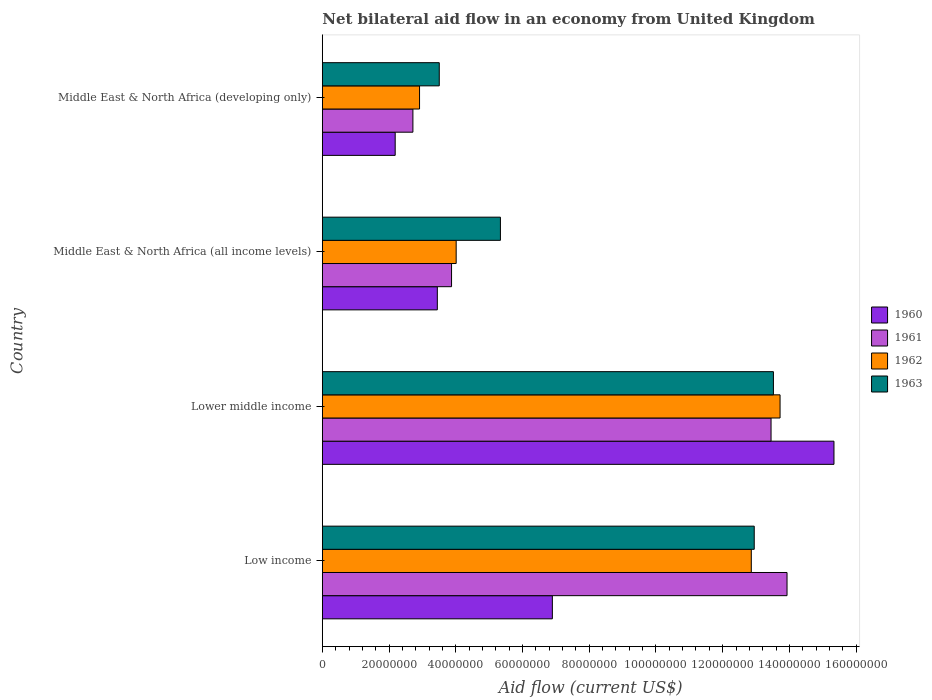How many different coloured bars are there?
Provide a succinct answer. 4. How many groups of bars are there?
Offer a terse response. 4. Are the number of bars per tick equal to the number of legend labels?
Offer a very short reply. Yes. How many bars are there on the 2nd tick from the top?
Provide a short and direct response. 4. How many bars are there on the 1st tick from the bottom?
Your response must be concise. 4. What is the label of the 1st group of bars from the top?
Keep it short and to the point. Middle East & North Africa (developing only). In how many cases, is the number of bars for a given country not equal to the number of legend labels?
Your response must be concise. 0. What is the net bilateral aid flow in 1962 in Low income?
Ensure brevity in your answer.  1.29e+08. Across all countries, what is the maximum net bilateral aid flow in 1961?
Give a very brief answer. 1.39e+08. Across all countries, what is the minimum net bilateral aid flow in 1962?
Your answer should be compact. 2.91e+07. In which country was the net bilateral aid flow in 1963 maximum?
Give a very brief answer. Lower middle income. In which country was the net bilateral aid flow in 1961 minimum?
Offer a terse response. Middle East & North Africa (developing only). What is the total net bilateral aid flow in 1961 in the graph?
Provide a succinct answer. 3.40e+08. What is the difference between the net bilateral aid flow in 1960 in Low income and that in Middle East & North Africa (all income levels)?
Your response must be concise. 3.45e+07. What is the difference between the net bilateral aid flow in 1961 in Lower middle income and the net bilateral aid flow in 1962 in Low income?
Make the answer very short. 5.92e+06. What is the average net bilateral aid flow in 1962 per country?
Make the answer very short. 8.38e+07. What is the difference between the net bilateral aid flow in 1963 and net bilateral aid flow in 1962 in Middle East & North Africa (developing only)?
Give a very brief answer. 5.91e+06. What is the ratio of the net bilateral aid flow in 1961 in Low income to that in Middle East & North Africa (all income levels)?
Offer a terse response. 3.6. Is the difference between the net bilateral aid flow in 1963 in Low income and Lower middle income greater than the difference between the net bilateral aid flow in 1962 in Low income and Lower middle income?
Offer a terse response. Yes. What is the difference between the highest and the second highest net bilateral aid flow in 1963?
Your answer should be very brief. 5.75e+06. What is the difference between the highest and the lowest net bilateral aid flow in 1962?
Make the answer very short. 1.08e+08. Is the sum of the net bilateral aid flow in 1962 in Lower middle income and Middle East & North Africa (all income levels) greater than the maximum net bilateral aid flow in 1960 across all countries?
Provide a succinct answer. Yes. What does the 3rd bar from the top in Low income represents?
Give a very brief answer. 1961. Is it the case that in every country, the sum of the net bilateral aid flow in 1960 and net bilateral aid flow in 1963 is greater than the net bilateral aid flow in 1961?
Ensure brevity in your answer.  Yes. How many bars are there?
Keep it short and to the point. 16. What is the difference between two consecutive major ticks on the X-axis?
Your answer should be compact. 2.00e+07. Are the values on the major ticks of X-axis written in scientific E-notation?
Offer a very short reply. No. Does the graph contain any zero values?
Keep it short and to the point. No. Where does the legend appear in the graph?
Provide a short and direct response. Center right. What is the title of the graph?
Make the answer very short. Net bilateral aid flow in an economy from United Kingdom. What is the label or title of the X-axis?
Your response must be concise. Aid flow (current US$). What is the Aid flow (current US$) in 1960 in Low income?
Provide a short and direct response. 6.90e+07. What is the Aid flow (current US$) in 1961 in Low income?
Your answer should be very brief. 1.39e+08. What is the Aid flow (current US$) in 1962 in Low income?
Provide a succinct answer. 1.29e+08. What is the Aid flow (current US$) in 1963 in Low income?
Your answer should be very brief. 1.29e+08. What is the Aid flow (current US$) of 1960 in Lower middle income?
Ensure brevity in your answer.  1.53e+08. What is the Aid flow (current US$) in 1961 in Lower middle income?
Offer a very short reply. 1.34e+08. What is the Aid flow (current US$) in 1962 in Lower middle income?
Offer a terse response. 1.37e+08. What is the Aid flow (current US$) of 1963 in Lower middle income?
Your response must be concise. 1.35e+08. What is the Aid flow (current US$) in 1960 in Middle East & North Africa (all income levels)?
Provide a succinct answer. 3.45e+07. What is the Aid flow (current US$) of 1961 in Middle East & North Africa (all income levels)?
Ensure brevity in your answer.  3.87e+07. What is the Aid flow (current US$) of 1962 in Middle East & North Africa (all income levels)?
Offer a very short reply. 4.01e+07. What is the Aid flow (current US$) in 1963 in Middle East & North Africa (all income levels)?
Your answer should be compact. 5.34e+07. What is the Aid flow (current US$) of 1960 in Middle East & North Africa (developing only)?
Provide a succinct answer. 2.18e+07. What is the Aid flow (current US$) of 1961 in Middle East & North Africa (developing only)?
Provide a succinct answer. 2.72e+07. What is the Aid flow (current US$) of 1962 in Middle East & North Africa (developing only)?
Make the answer very short. 2.91e+07. What is the Aid flow (current US$) of 1963 in Middle East & North Africa (developing only)?
Offer a very short reply. 3.50e+07. Across all countries, what is the maximum Aid flow (current US$) in 1960?
Make the answer very short. 1.53e+08. Across all countries, what is the maximum Aid flow (current US$) of 1961?
Your response must be concise. 1.39e+08. Across all countries, what is the maximum Aid flow (current US$) of 1962?
Ensure brevity in your answer.  1.37e+08. Across all countries, what is the maximum Aid flow (current US$) in 1963?
Your answer should be very brief. 1.35e+08. Across all countries, what is the minimum Aid flow (current US$) of 1960?
Offer a very short reply. 2.18e+07. Across all countries, what is the minimum Aid flow (current US$) of 1961?
Keep it short and to the point. 2.72e+07. Across all countries, what is the minimum Aid flow (current US$) in 1962?
Provide a succinct answer. 2.91e+07. Across all countries, what is the minimum Aid flow (current US$) of 1963?
Offer a terse response. 3.50e+07. What is the total Aid flow (current US$) in 1960 in the graph?
Give a very brief answer. 2.79e+08. What is the total Aid flow (current US$) in 1961 in the graph?
Make the answer very short. 3.40e+08. What is the total Aid flow (current US$) of 1962 in the graph?
Give a very brief answer. 3.35e+08. What is the total Aid flow (current US$) of 1963 in the graph?
Your answer should be compact. 3.53e+08. What is the difference between the Aid flow (current US$) of 1960 in Low income and that in Lower middle income?
Your answer should be very brief. -8.44e+07. What is the difference between the Aid flow (current US$) of 1961 in Low income and that in Lower middle income?
Provide a short and direct response. 4.79e+06. What is the difference between the Aid flow (current US$) of 1962 in Low income and that in Lower middle income?
Provide a short and direct response. -8.62e+06. What is the difference between the Aid flow (current US$) of 1963 in Low income and that in Lower middle income?
Offer a very short reply. -5.75e+06. What is the difference between the Aid flow (current US$) in 1960 in Low income and that in Middle East & North Africa (all income levels)?
Provide a succinct answer. 3.45e+07. What is the difference between the Aid flow (current US$) of 1961 in Low income and that in Middle East & North Africa (all income levels)?
Offer a terse response. 1.01e+08. What is the difference between the Aid flow (current US$) in 1962 in Low income and that in Middle East & North Africa (all income levels)?
Ensure brevity in your answer.  8.85e+07. What is the difference between the Aid flow (current US$) of 1963 in Low income and that in Middle East & North Africa (all income levels)?
Offer a terse response. 7.61e+07. What is the difference between the Aid flow (current US$) in 1960 in Low income and that in Middle East & North Africa (developing only)?
Make the answer very short. 4.71e+07. What is the difference between the Aid flow (current US$) of 1961 in Low income and that in Middle East & North Africa (developing only)?
Provide a succinct answer. 1.12e+08. What is the difference between the Aid flow (current US$) in 1962 in Low income and that in Middle East & North Africa (developing only)?
Provide a succinct answer. 9.94e+07. What is the difference between the Aid flow (current US$) in 1963 in Low income and that in Middle East & North Africa (developing only)?
Your response must be concise. 9.44e+07. What is the difference between the Aid flow (current US$) in 1960 in Lower middle income and that in Middle East & North Africa (all income levels)?
Provide a succinct answer. 1.19e+08. What is the difference between the Aid flow (current US$) of 1961 in Lower middle income and that in Middle East & North Africa (all income levels)?
Provide a short and direct response. 9.58e+07. What is the difference between the Aid flow (current US$) of 1962 in Lower middle income and that in Middle East & North Africa (all income levels)?
Give a very brief answer. 9.71e+07. What is the difference between the Aid flow (current US$) of 1963 in Lower middle income and that in Middle East & North Africa (all income levels)?
Your answer should be compact. 8.18e+07. What is the difference between the Aid flow (current US$) in 1960 in Lower middle income and that in Middle East & North Africa (developing only)?
Your answer should be very brief. 1.32e+08. What is the difference between the Aid flow (current US$) of 1961 in Lower middle income and that in Middle East & North Africa (developing only)?
Provide a short and direct response. 1.07e+08. What is the difference between the Aid flow (current US$) of 1962 in Lower middle income and that in Middle East & North Africa (developing only)?
Your answer should be compact. 1.08e+08. What is the difference between the Aid flow (current US$) in 1963 in Lower middle income and that in Middle East & North Africa (developing only)?
Provide a succinct answer. 1.00e+08. What is the difference between the Aid flow (current US$) in 1960 in Middle East & North Africa (all income levels) and that in Middle East & North Africa (developing only)?
Your answer should be very brief. 1.26e+07. What is the difference between the Aid flow (current US$) in 1961 in Middle East & North Africa (all income levels) and that in Middle East & North Africa (developing only)?
Your answer should be compact. 1.16e+07. What is the difference between the Aid flow (current US$) in 1962 in Middle East & North Africa (all income levels) and that in Middle East & North Africa (developing only)?
Provide a succinct answer. 1.10e+07. What is the difference between the Aid flow (current US$) of 1963 in Middle East & North Africa (all income levels) and that in Middle East & North Africa (developing only)?
Provide a short and direct response. 1.83e+07. What is the difference between the Aid flow (current US$) in 1960 in Low income and the Aid flow (current US$) in 1961 in Lower middle income?
Make the answer very short. -6.56e+07. What is the difference between the Aid flow (current US$) in 1960 in Low income and the Aid flow (current US$) in 1962 in Lower middle income?
Provide a succinct answer. -6.82e+07. What is the difference between the Aid flow (current US$) in 1960 in Low income and the Aid flow (current US$) in 1963 in Lower middle income?
Make the answer very short. -6.63e+07. What is the difference between the Aid flow (current US$) of 1961 in Low income and the Aid flow (current US$) of 1962 in Lower middle income?
Ensure brevity in your answer.  2.09e+06. What is the difference between the Aid flow (current US$) in 1961 in Low income and the Aid flow (current US$) in 1963 in Lower middle income?
Make the answer very short. 4.08e+06. What is the difference between the Aid flow (current US$) in 1962 in Low income and the Aid flow (current US$) in 1963 in Lower middle income?
Provide a succinct answer. -6.63e+06. What is the difference between the Aid flow (current US$) in 1960 in Low income and the Aid flow (current US$) in 1961 in Middle East & North Africa (all income levels)?
Give a very brief answer. 3.02e+07. What is the difference between the Aid flow (current US$) in 1960 in Low income and the Aid flow (current US$) in 1962 in Middle East & North Africa (all income levels)?
Your response must be concise. 2.88e+07. What is the difference between the Aid flow (current US$) in 1960 in Low income and the Aid flow (current US$) in 1963 in Middle East & North Africa (all income levels)?
Keep it short and to the point. 1.56e+07. What is the difference between the Aid flow (current US$) in 1961 in Low income and the Aid flow (current US$) in 1962 in Middle East & North Africa (all income levels)?
Offer a very short reply. 9.92e+07. What is the difference between the Aid flow (current US$) of 1961 in Low income and the Aid flow (current US$) of 1963 in Middle East & North Africa (all income levels)?
Ensure brevity in your answer.  8.59e+07. What is the difference between the Aid flow (current US$) of 1962 in Low income and the Aid flow (current US$) of 1963 in Middle East & North Africa (all income levels)?
Ensure brevity in your answer.  7.52e+07. What is the difference between the Aid flow (current US$) of 1960 in Low income and the Aid flow (current US$) of 1961 in Middle East & North Africa (developing only)?
Ensure brevity in your answer.  4.18e+07. What is the difference between the Aid flow (current US$) in 1960 in Low income and the Aid flow (current US$) in 1962 in Middle East & North Africa (developing only)?
Make the answer very short. 3.98e+07. What is the difference between the Aid flow (current US$) in 1960 in Low income and the Aid flow (current US$) in 1963 in Middle East & North Africa (developing only)?
Your answer should be compact. 3.39e+07. What is the difference between the Aid flow (current US$) in 1961 in Low income and the Aid flow (current US$) in 1962 in Middle East & North Africa (developing only)?
Offer a very short reply. 1.10e+08. What is the difference between the Aid flow (current US$) in 1961 in Low income and the Aid flow (current US$) in 1963 in Middle East & North Africa (developing only)?
Offer a very short reply. 1.04e+08. What is the difference between the Aid flow (current US$) in 1962 in Low income and the Aid flow (current US$) in 1963 in Middle East & North Africa (developing only)?
Your answer should be very brief. 9.35e+07. What is the difference between the Aid flow (current US$) in 1960 in Lower middle income and the Aid flow (current US$) in 1961 in Middle East & North Africa (all income levels)?
Offer a very short reply. 1.15e+08. What is the difference between the Aid flow (current US$) in 1960 in Lower middle income and the Aid flow (current US$) in 1962 in Middle East & North Africa (all income levels)?
Your answer should be compact. 1.13e+08. What is the difference between the Aid flow (current US$) of 1960 in Lower middle income and the Aid flow (current US$) of 1963 in Middle East & North Africa (all income levels)?
Provide a succinct answer. 1.00e+08. What is the difference between the Aid flow (current US$) of 1961 in Lower middle income and the Aid flow (current US$) of 1962 in Middle East & North Africa (all income levels)?
Give a very brief answer. 9.44e+07. What is the difference between the Aid flow (current US$) in 1961 in Lower middle income and the Aid flow (current US$) in 1963 in Middle East & North Africa (all income levels)?
Ensure brevity in your answer.  8.11e+07. What is the difference between the Aid flow (current US$) in 1962 in Lower middle income and the Aid flow (current US$) in 1963 in Middle East & North Africa (all income levels)?
Keep it short and to the point. 8.38e+07. What is the difference between the Aid flow (current US$) in 1960 in Lower middle income and the Aid flow (current US$) in 1961 in Middle East & North Africa (developing only)?
Make the answer very short. 1.26e+08. What is the difference between the Aid flow (current US$) in 1960 in Lower middle income and the Aid flow (current US$) in 1962 in Middle East & North Africa (developing only)?
Your response must be concise. 1.24e+08. What is the difference between the Aid flow (current US$) of 1960 in Lower middle income and the Aid flow (current US$) of 1963 in Middle East & North Africa (developing only)?
Make the answer very short. 1.18e+08. What is the difference between the Aid flow (current US$) in 1961 in Lower middle income and the Aid flow (current US$) in 1962 in Middle East & North Africa (developing only)?
Your response must be concise. 1.05e+08. What is the difference between the Aid flow (current US$) of 1961 in Lower middle income and the Aid flow (current US$) of 1963 in Middle East & North Africa (developing only)?
Your answer should be very brief. 9.94e+07. What is the difference between the Aid flow (current US$) in 1962 in Lower middle income and the Aid flow (current US$) in 1963 in Middle East & North Africa (developing only)?
Keep it short and to the point. 1.02e+08. What is the difference between the Aid flow (current US$) in 1960 in Middle East & North Africa (all income levels) and the Aid flow (current US$) in 1961 in Middle East & North Africa (developing only)?
Your answer should be compact. 7.32e+06. What is the difference between the Aid flow (current US$) of 1960 in Middle East & North Africa (all income levels) and the Aid flow (current US$) of 1962 in Middle East & North Africa (developing only)?
Keep it short and to the point. 5.33e+06. What is the difference between the Aid flow (current US$) of 1960 in Middle East & North Africa (all income levels) and the Aid flow (current US$) of 1963 in Middle East & North Africa (developing only)?
Your answer should be very brief. -5.80e+05. What is the difference between the Aid flow (current US$) in 1961 in Middle East & North Africa (all income levels) and the Aid flow (current US$) in 1962 in Middle East & North Africa (developing only)?
Keep it short and to the point. 9.59e+06. What is the difference between the Aid flow (current US$) in 1961 in Middle East & North Africa (all income levels) and the Aid flow (current US$) in 1963 in Middle East & North Africa (developing only)?
Make the answer very short. 3.68e+06. What is the difference between the Aid flow (current US$) of 1962 in Middle East & North Africa (all income levels) and the Aid flow (current US$) of 1963 in Middle East & North Africa (developing only)?
Ensure brevity in your answer.  5.07e+06. What is the average Aid flow (current US$) of 1960 per country?
Your answer should be compact. 6.97e+07. What is the average Aid flow (current US$) in 1961 per country?
Ensure brevity in your answer.  8.49e+07. What is the average Aid flow (current US$) of 1962 per country?
Your answer should be compact. 8.38e+07. What is the average Aid flow (current US$) in 1963 per country?
Your answer should be compact. 8.83e+07. What is the difference between the Aid flow (current US$) of 1960 and Aid flow (current US$) of 1961 in Low income?
Give a very brief answer. -7.03e+07. What is the difference between the Aid flow (current US$) in 1960 and Aid flow (current US$) in 1962 in Low income?
Ensure brevity in your answer.  -5.96e+07. What is the difference between the Aid flow (current US$) of 1960 and Aid flow (current US$) of 1963 in Low income?
Provide a short and direct response. -6.05e+07. What is the difference between the Aid flow (current US$) in 1961 and Aid flow (current US$) in 1962 in Low income?
Provide a succinct answer. 1.07e+07. What is the difference between the Aid flow (current US$) in 1961 and Aid flow (current US$) in 1963 in Low income?
Ensure brevity in your answer.  9.83e+06. What is the difference between the Aid flow (current US$) of 1962 and Aid flow (current US$) of 1963 in Low income?
Offer a terse response. -8.80e+05. What is the difference between the Aid flow (current US$) in 1960 and Aid flow (current US$) in 1961 in Lower middle income?
Keep it short and to the point. 1.89e+07. What is the difference between the Aid flow (current US$) in 1960 and Aid flow (current US$) in 1962 in Lower middle income?
Offer a terse response. 1.62e+07. What is the difference between the Aid flow (current US$) in 1960 and Aid flow (current US$) in 1963 in Lower middle income?
Make the answer very short. 1.82e+07. What is the difference between the Aid flow (current US$) in 1961 and Aid flow (current US$) in 1962 in Lower middle income?
Make the answer very short. -2.70e+06. What is the difference between the Aid flow (current US$) in 1961 and Aid flow (current US$) in 1963 in Lower middle income?
Offer a very short reply. -7.10e+05. What is the difference between the Aid flow (current US$) of 1962 and Aid flow (current US$) of 1963 in Lower middle income?
Your response must be concise. 1.99e+06. What is the difference between the Aid flow (current US$) in 1960 and Aid flow (current US$) in 1961 in Middle East & North Africa (all income levels)?
Ensure brevity in your answer.  -4.26e+06. What is the difference between the Aid flow (current US$) of 1960 and Aid flow (current US$) of 1962 in Middle East & North Africa (all income levels)?
Keep it short and to the point. -5.65e+06. What is the difference between the Aid flow (current US$) in 1960 and Aid flow (current US$) in 1963 in Middle East & North Africa (all income levels)?
Offer a terse response. -1.89e+07. What is the difference between the Aid flow (current US$) of 1961 and Aid flow (current US$) of 1962 in Middle East & North Africa (all income levels)?
Your answer should be compact. -1.39e+06. What is the difference between the Aid flow (current US$) of 1961 and Aid flow (current US$) of 1963 in Middle East & North Africa (all income levels)?
Give a very brief answer. -1.46e+07. What is the difference between the Aid flow (current US$) in 1962 and Aid flow (current US$) in 1963 in Middle East & North Africa (all income levels)?
Offer a very short reply. -1.33e+07. What is the difference between the Aid flow (current US$) in 1960 and Aid flow (current US$) in 1961 in Middle East & North Africa (developing only)?
Your response must be concise. -5.31e+06. What is the difference between the Aid flow (current US$) of 1960 and Aid flow (current US$) of 1962 in Middle East & North Africa (developing only)?
Make the answer very short. -7.30e+06. What is the difference between the Aid flow (current US$) of 1960 and Aid flow (current US$) of 1963 in Middle East & North Africa (developing only)?
Offer a terse response. -1.32e+07. What is the difference between the Aid flow (current US$) in 1961 and Aid flow (current US$) in 1962 in Middle East & North Africa (developing only)?
Your response must be concise. -1.99e+06. What is the difference between the Aid flow (current US$) of 1961 and Aid flow (current US$) of 1963 in Middle East & North Africa (developing only)?
Keep it short and to the point. -7.90e+06. What is the difference between the Aid flow (current US$) in 1962 and Aid flow (current US$) in 1963 in Middle East & North Africa (developing only)?
Your answer should be very brief. -5.91e+06. What is the ratio of the Aid flow (current US$) in 1960 in Low income to that in Lower middle income?
Keep it short and to the point. 0.45. What is the ratio of the Aid flow (current US$) in 1961 in Low income to that in Lower middle income?
Provide a short and direct response. 1.04. What is the ratio of the Aid flow (current US$) in 1962 in Low income to that in Lower middle income?
Give a very brief answer. 0.94. What is the ratio of the Aid flow (current US$) in 1963 in Low income to that in Lower middle income?
Your answer should be very brief. 0.96. What is the ratio of the Aid flow (current US$) of 1960 in Low income to that in Middle East & North Africa (all income levels)?
Keep it short and to the point. 2. What is the ratio of the Aid flow (current US$) of 1961 in Low income to that in Middle East & North Africa (all income levels)?
Make the answer very short. 3.6. What is the ratio of the Aid flow (current US$) in 1962 in Low income to that in Middle East & North Africa (all income levels)?
Give a very brief answer. 3.2. What is the ratio of the Aid flow (current US$) in 1963 in Low income to that in Middle East & North Africa (all income levels)?
Provide a succinct answer. 2.43. What is the ratio of the Aid flow (current US$) of 1960 in Low income to that in Middle East & North Africa (developing only)?
Make the answer very short. 3.16. What is the ratio of the Aid flow (current US$) of 1961 in Low income to that in Middle East & North Africa (developing only)?
Your answer should be very brief. 5.13. What is the ratio of the Aid flow (current US$) of 1962 in Low income to that in Middle East & North Africa (developing only)?
Provide a succinct answer. 4.41. What is the ratio of the Aid flow (current US$) in 1963 in Low income to that in Middle East & North Africa (developing only)?
Provide a short and direct response. 3.69. What is the ratio of the Aid flow (current US$) of 1960 in Lower middle income to that in Middle East & North Africa (all income levels)?
Provide a succinct answer. 4.45. What is the ratio of the Aid flow (current US$) in 1961 in Lower middle income to that in Middle East & North Africa (all income levels)?
Provide a succinct answer. 3.47. What is the ratio of the Aid flow (current US$) of 1962 in Lower middle income to that in Middle East & North Africa (all income levels)?
Your answer should be compact. 3.42. What is the ratio of the Aid flow (current US$) of 1963 in Lower middle income to that in Middle East & North Africa (all income levels)?
Keep it short and to the point. 2.53. What is the ratio of the Aid flow (current US$) in 1960 in Lower middle income to that in Middle East & North Africa (developing only)?
Give a very brief answer. 7.02. What is the ratio of the Aid flow (current US$) in 1961 in Lower middle income to that in Middle East & North Africa (developing only)?
Provide a succinct answer. 4.95. What is the ratio of the Aid flow (current US$) of 1962 in Lower middle income to that in Middle East & North Africa (developing only)?
Your response must be concise. 4.71. What is the ratio of the Aid flow (current US$) in 1963 in Lower middle income to that in Middle East & North Africa (developing only)?
Provide a succinct answer. 3.86. What is the ratio of the Aid flow (current US$) of 1960 in Middle East & North Africa (all income levels) to that in Middle East & North Africa (developing only)?
Provide a succinct answer. 1.58. What is the ratio of the Aid flow (current US$) of 1961 in Middle East & North Africa (all income levels) to that in Middle East & North Africa (developing only)?
Make the answer very short. 1.43. What is the ratio of the Aid flow (current US$) in 1962 in Middle East & North Africa (all income levels) to that in Middle East & North Africa (developing only)?
Make the answer very short. 1.38. What is the ratio of the Aid flow (current US$) of 1963 in Middle East & North Africa (all income levels) to that in Middle East & North Africa (developing only)?
Offer a very short reply. 1.52. What is the difference between the highest and the second highest Aid flow (current US$) of 1960?
Provide a succinct answer. 8.44e+07. What is the difference between the highest and the second highest Aid flow (current US$) in 1961?
Your answer should be very brief. 4.79e+06. What is the difference between the highest and the second highest Aid flow (current US$) of 1962?
Your answer should be compact. 8.62e+06. What is the difference between the highest and the second highest Aid flow (current US$) of 1963?
Offer a terse response. 5.75e+06. What is the difference between the highest and the lowest Aid flow (current US$) of 1960?
Keep it short and to the point. 1.32e+08. What is the difference between the highest and the lowest Aid flow (current US$) of 1961?
Give a very brief answer. 1.12e+08. What is the difference between the highest and the lowest Aid flow (current US$) of 1962?
Offer a very short reply. 1.08e+08. What is the difference between the highest and the lowest Aid flow (current US$) of 1963?
Offer a terse response. 1.00e+08. 